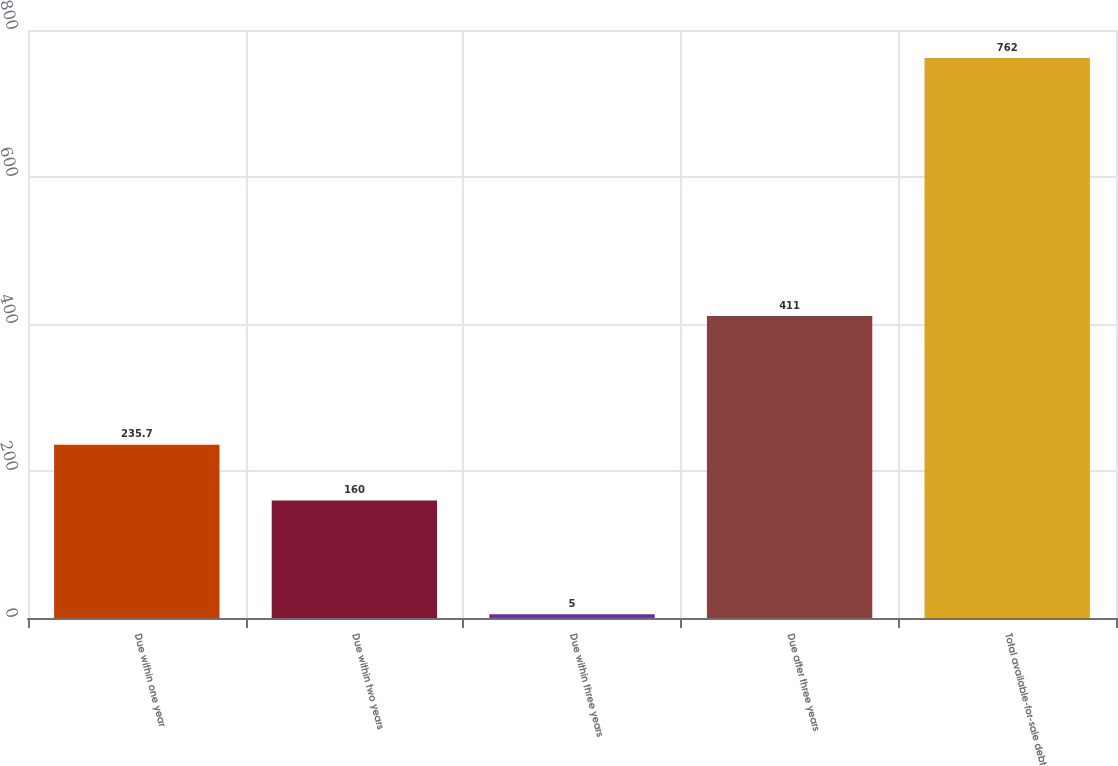Convert chart. <chart><loc_0><loc_0><loc_500><loc_500><bar_chart><fcel>Due within one year<fcel>Due within two years<fcel>Due within three years<fcel>Due after three years<fcel>Total available-for-sale debt<nl><fcel>235.7<fcel>160<fcel>5<fcel>411<fcel>762<nl></chart> 